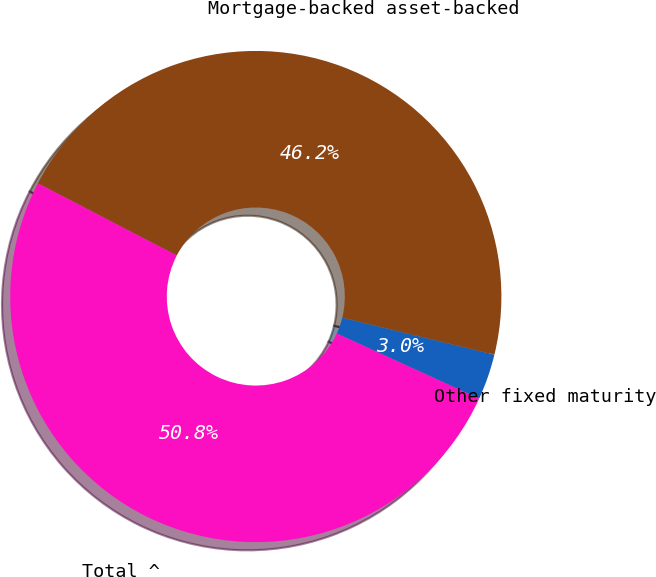Convert chart to OTSL. <chart><loc_0><loc_0><loc_500><loc_500><pie_chart><fcel>Other fixed maturity<fcel>Mortgage-backed asset-backed<fcel>Total ^<nl><fcel>3.02%<fcel>46.18%<fcel>50.8%<nl></chart> 